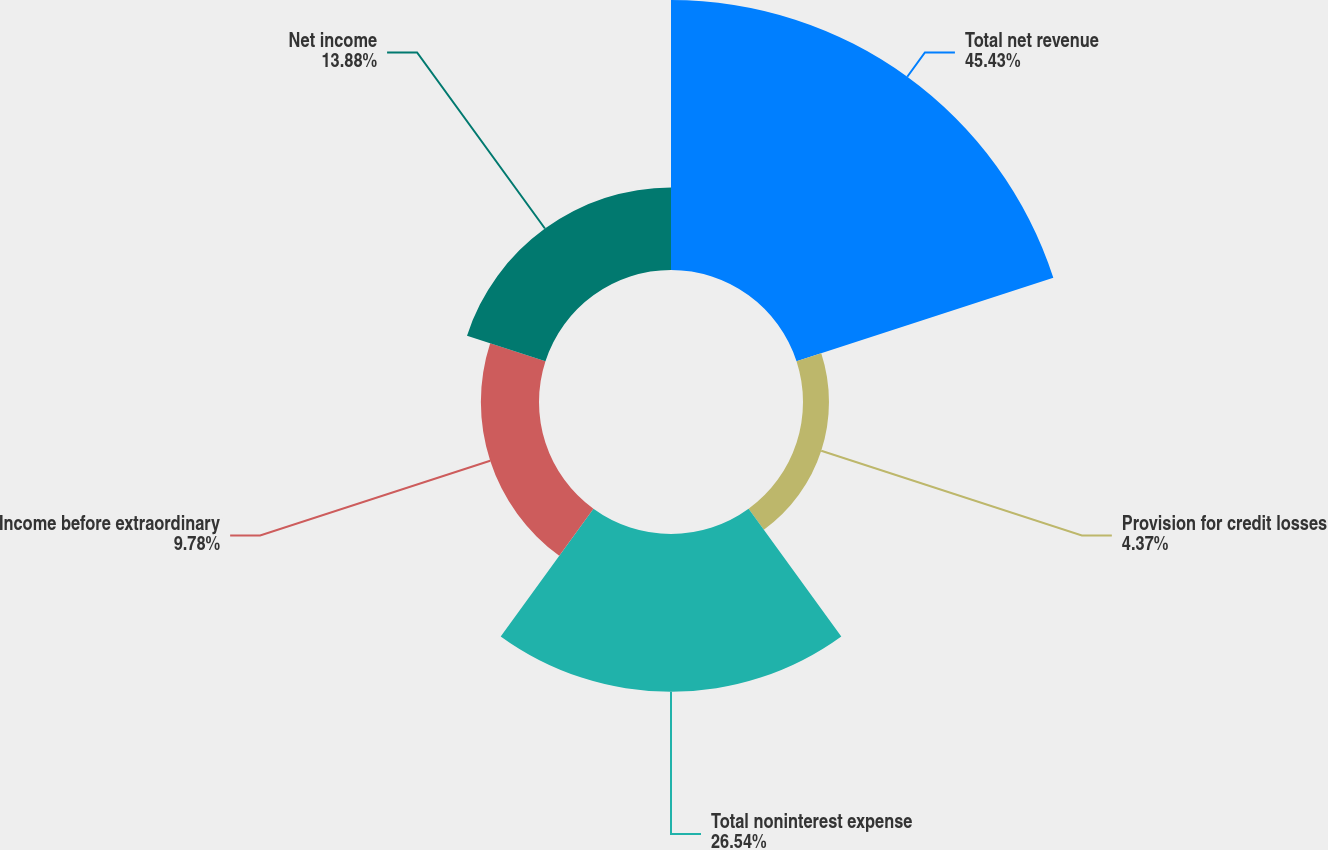Convert chart. <chart><loc_0><loc_0><loc_500><loc_500><pie_chart><fcel>Total net revenue<fcel>Provision for credit losses<fcel>Total noninterest expense<fcel>Income before extraordinary<fcel>Net income<nl><fcel>45.43%<fcel>4.37%<fcel>26.54%<fcel>9.78%<fcel>13.88%<nl></chart> 